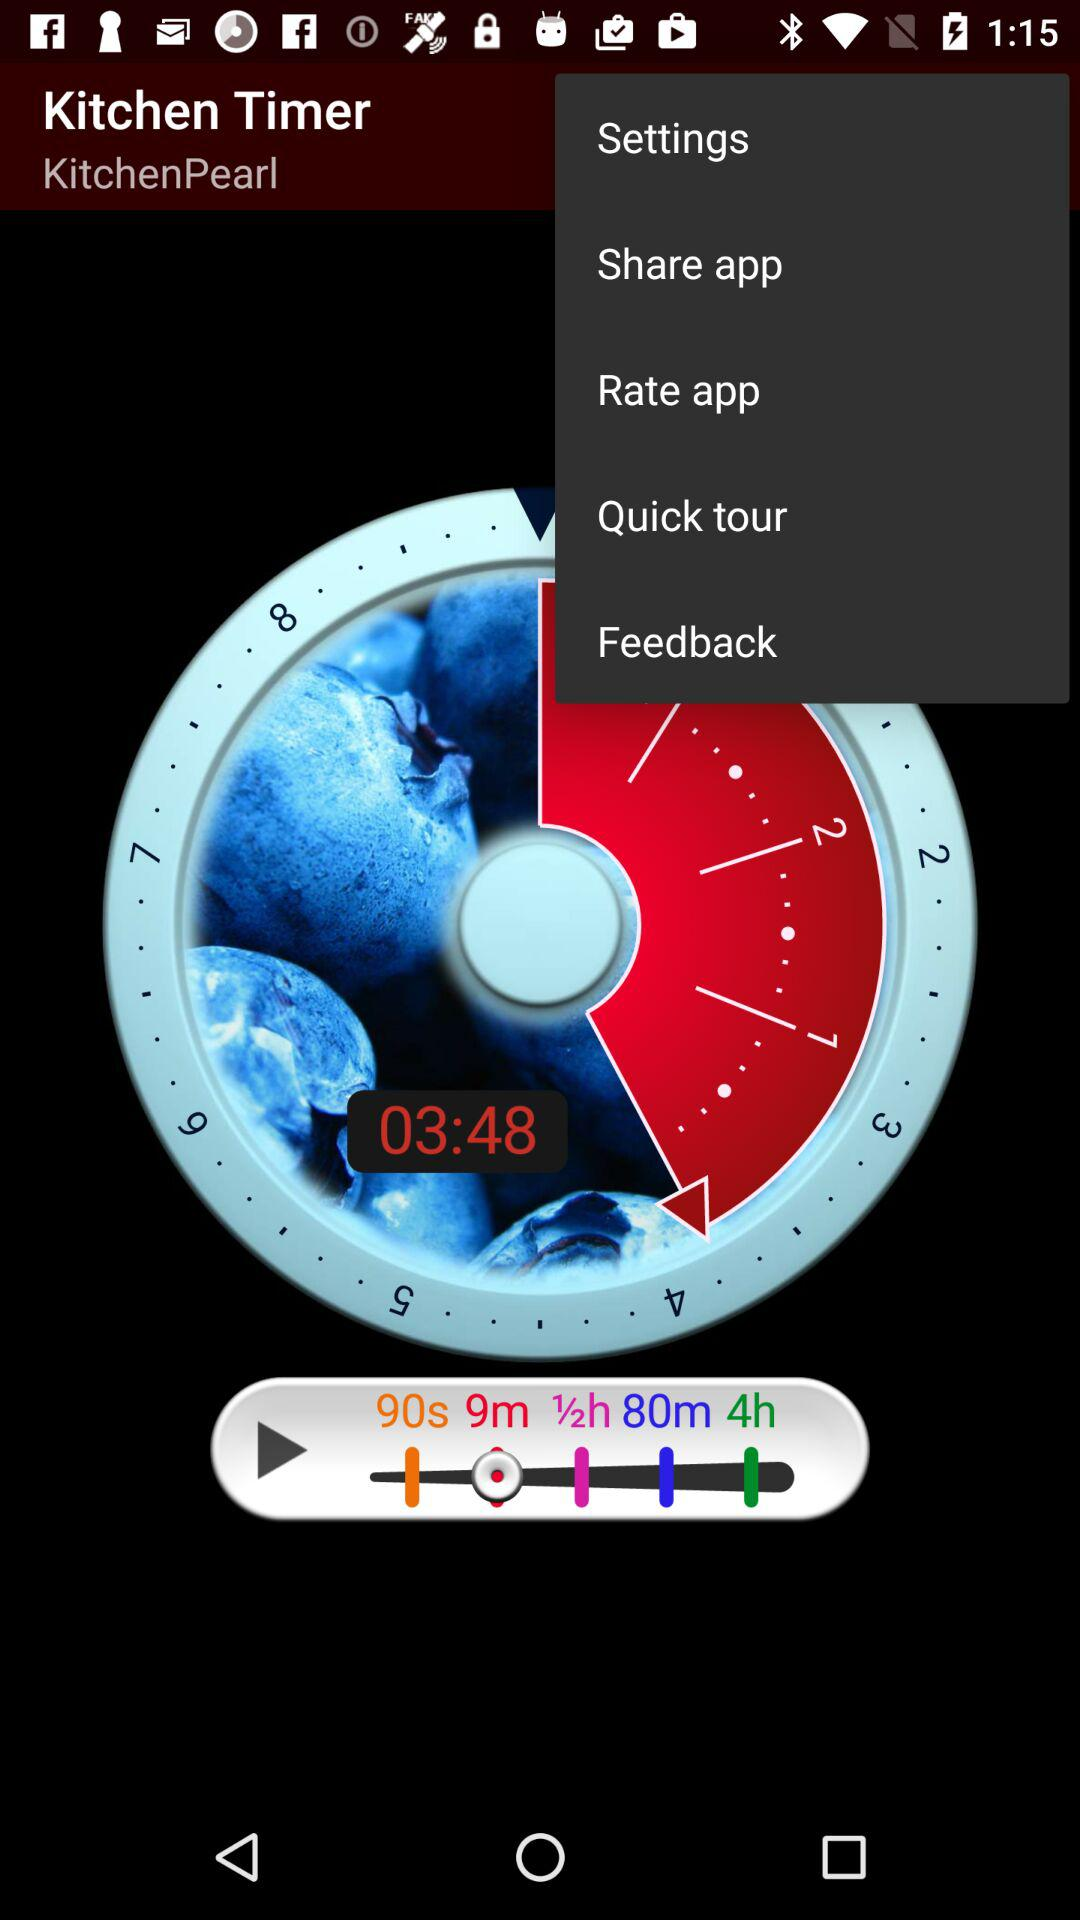What is the time shown on the timer? The time shown on the timer is 03:48. 